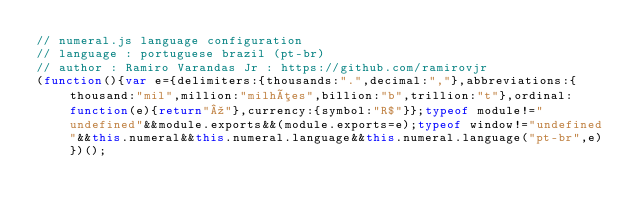<code> <loc_0><loc_0><loc_500><loc_500><_JavaScript_>// numeral.js language configuration
// language : portuguese brazil (pt-br)
// author : Ramiro Varandas Jr : https://github.com/ramirovjr
(function(){var e={delimiters:{thousands:".",decimal:","},abbreviations:{thousand:"mil",million:"milhões",billion:"b",trillion:"t"},ordinal:function(e){return"º"},currency:{symbol:"R$"}};typeof module!="undefined"&&module.exports&&(module.exports=e);typeof window!="undefined"&&this.numeral&&this.numeral.language&&this.numeral.language("pt-br",e)})();</code> 